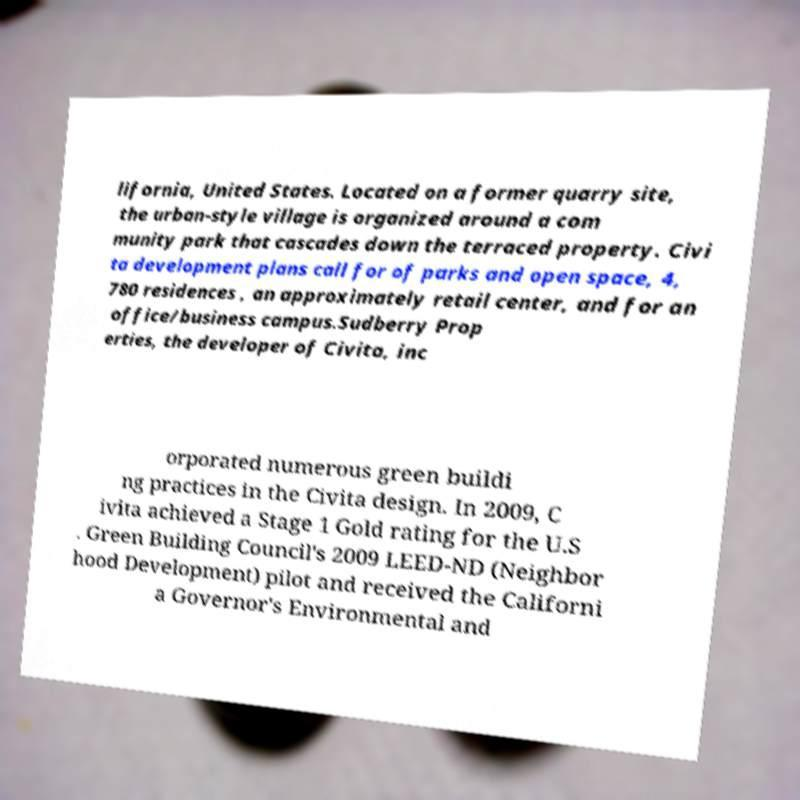Please read and relay the text visible in this image. What does it say? lifornia, United States. Located on a former quarry site, the urban-style village is organized around a com munity park that cascades down the terraced property. Civi ta development plans call for of parks and open space, 4, 780 residences , an approximately retail center, and for an office/business campus.Sudberry Prop erties, the developer of Civita, inc orporated numerous green buildi ng practices in the Civita design. In 2009, C ivita achieved a Stage 1 Gold rating for the U.S . Green Building Council's 2009 LEED-ND (Neighbor hood Development) pilot and received the Californi a Governor's Environmental and 